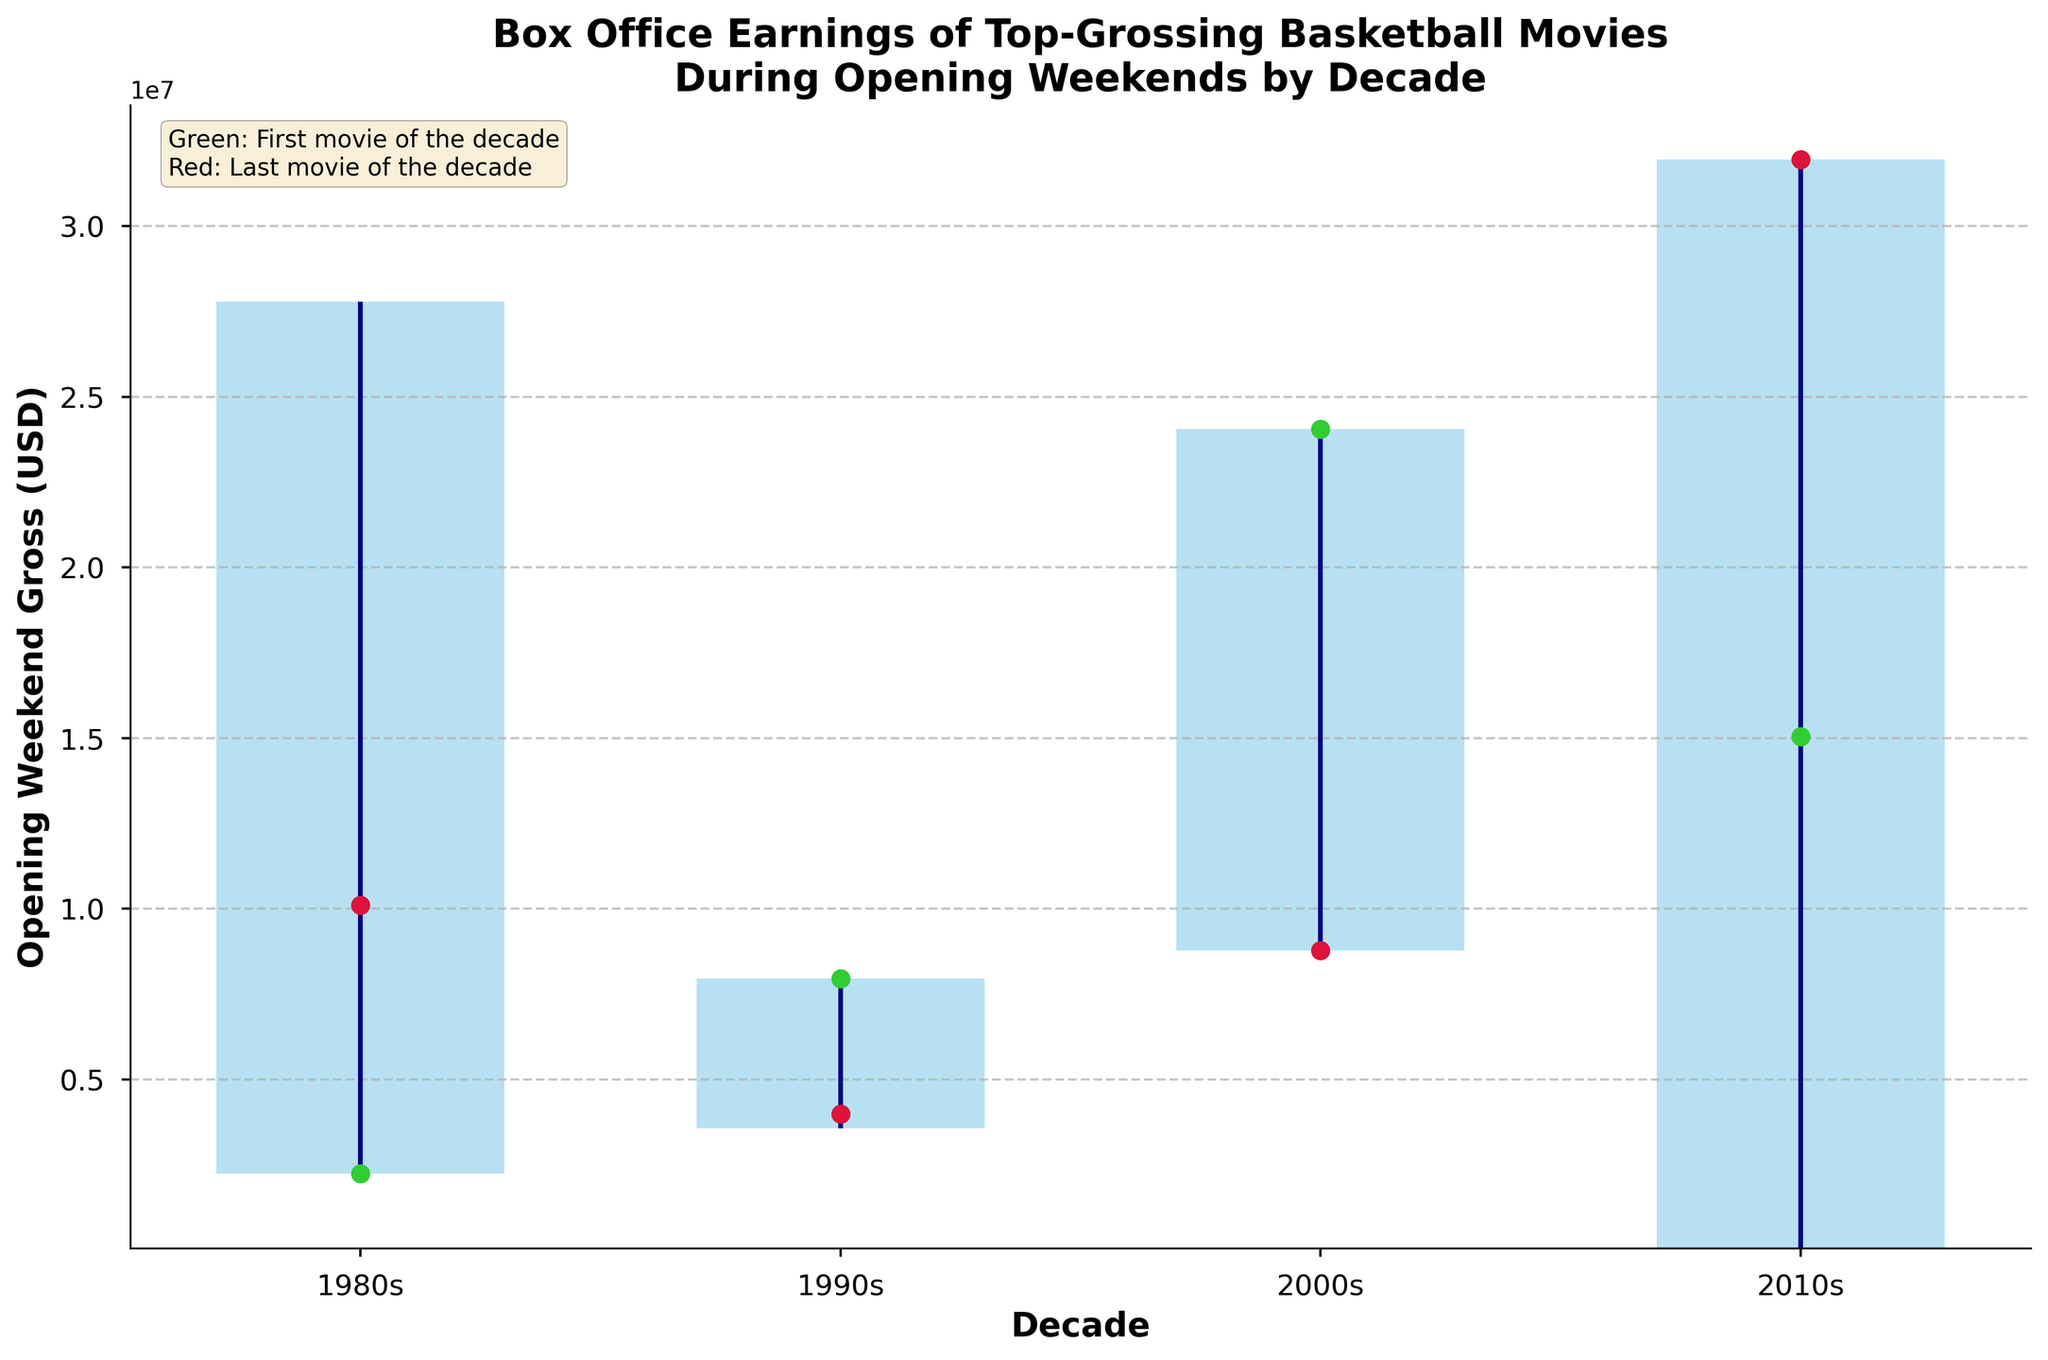Which decade had the highest opening weekend gross for a basketball movie? To determine this, identify the highest value of the bar for each decade. The 2010s show the highest peak with "Space Jam: A New Legacy" grossing the most.
Answer: 2010s Which decade had the widest range of opening weekend grosses? Look at the height of the blue bars and the length of the vertical blue lines. The 2010s have the widest range between the lowest and highest values.
Answer: 2010s What is the color used to mark the first movie of each decade? Since it is specified in the plot, "Green: First movie of the decade" means green dots indicate the first movies of each decade.
Answer: Green What's the difference between the opening weekend gross of the first movie and the last movie of the 2000s? Identify the green and red dots for the 2000s. The first movie "Coach Carter" has about 24 million USD while the last movie "Love & Basketball" has about 8.8 million USD. The difference is: 24,046,736 - 8,769,766 = 15,276,970 USD.
Answer: 15.28 million USD Which decade saw the lowest opening weekend gross for a basketball movie? Look for the shortest vertical blue line. The 2010s have the lowest point with "Thunderstruck" grossing the least, around 63,673 USD.
Answer: 2010s What is the average of the lowest opening weekend grosses across the four decades? The lowest grosses for the 1980s, 1990s, 2000s, and 2010s are 2,236,167, 3,569,132, 8,769,766, and 63,673 USD respectively. Calculate the average: (2,236,167 + 3,569,132 + 8,769,766 + 63,673) / 4 = 3,159,184.5 USD.
Answer: 3.16 million USD During which decade did movies show the most consistent opening weekend gross? Check for the decade with the shortest range from lowest to highest, indicated by the shortest blue vertical bar. The 1990s have the shortest range, thus showing the most consistency.
Answer: 1990s Which movie had the highest opening weekend gross in the 2000s? Examine the highest point for the blue vertical bar in the 2000s. "Coach Carter" has the highest opening weekend gross in the 2000s, around 24 million USD.
Answer: Coach Carter 